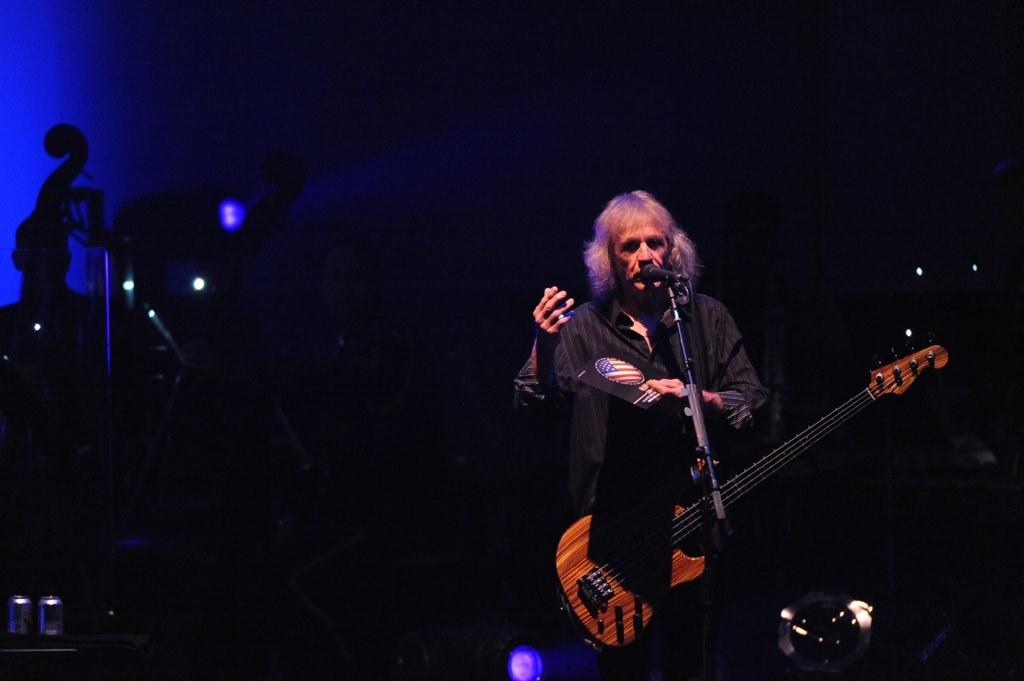What is the main subject of the image? There is a person in the image. What is the person holding in the image? The person is holding a guitar. What object is in front of the person? There is a microphone in front of the person. What type of pin can be seen on the person's clothing in the image? There is no pin visible on the person's clothing in the image. How does the person's expression show disgust in the image? The person's expression does not show disgust in the image; there is no indication of emotion in the image. 